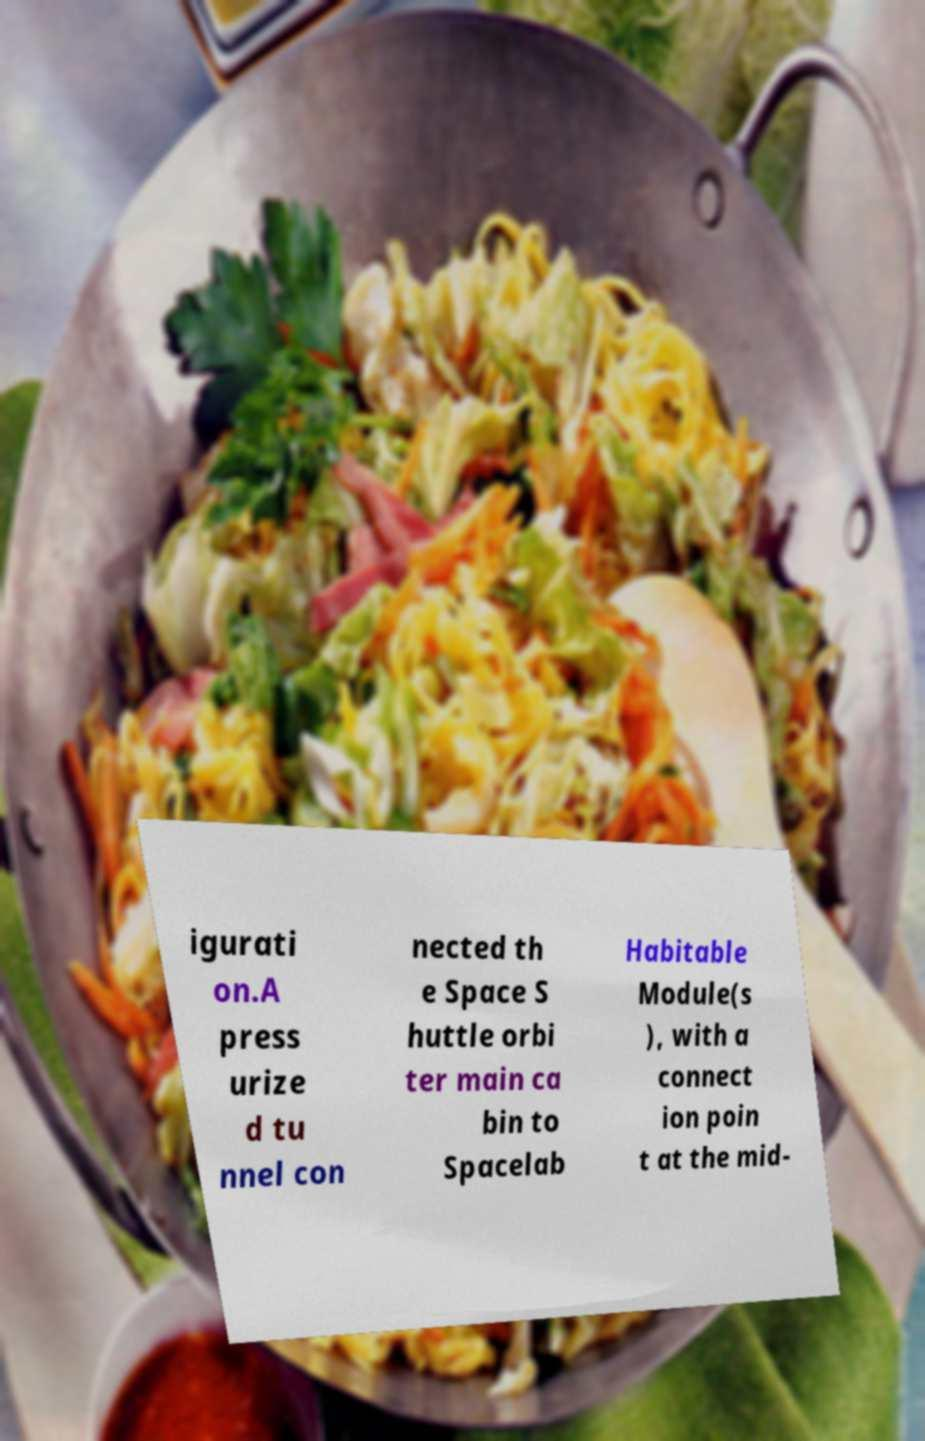I need the written content from this picture converted into text. Can you do that? igurati on.A press urize d tu nnel con nected th e Space S huttle orbi ter main ca bin to Spacelab Habitable Module(s ), with a connect ion poin t at the mid- 